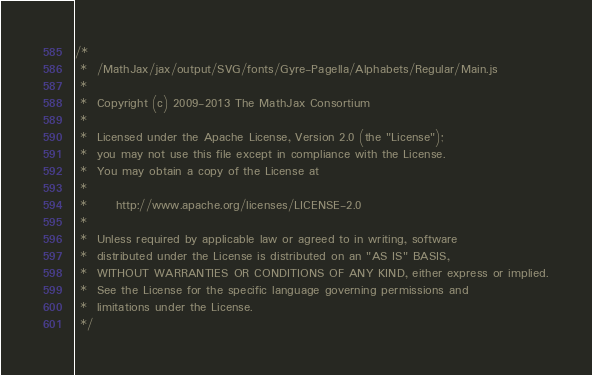<code> <loc_0><loc_0><loc_500><loc_500><_JavaScript_>/*
 *  /MathJax/jax/output/SVG/fonts/Gyre-Pagella/Alphabets/Regular/Main.js
 *
 *  Copyright (c) 2009-2013 The MathJax Consortium
 *
 *  Licensed under the Apache License, Version 2.0 (the "License");
 *  you may not use this file except in compliance with the License.
 *  You may obtain a copy of the License at
 *
 *      http://www.apache.org/licenses/LICENSE-2.0
 *
 *  Unless required by applicable law or agreed to in writing, software
 *  distributed under the License is distributed on an "AS IS" BASIS,
 *  WITHOUT WARRANTIES OR CONDITIONS OF ANY KIND, either express or implied.
 *  See the License for the specific language governing permissions and
 *  limitations under the License.
 */
</code> 